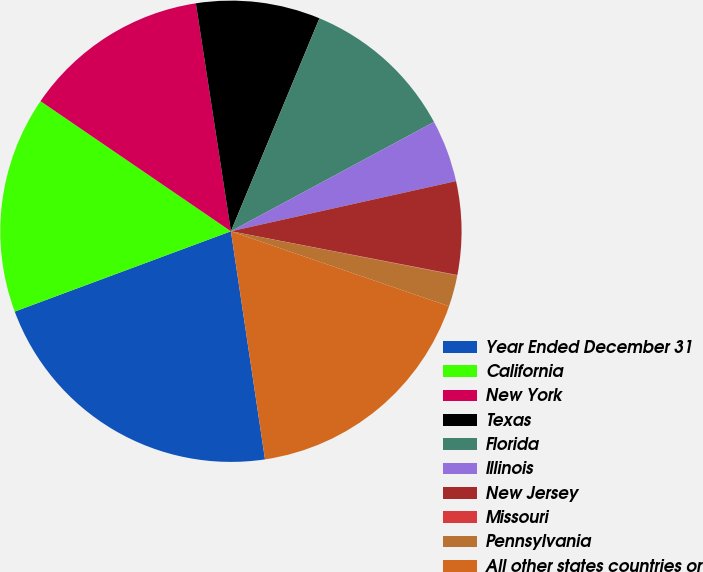Convert chart. <chart><loc_0><loc_0><loc_500><loc_500><pie_chart><fcel>Year Ended December 31<fcel>California<fcel>New York<fcel>Texas<fcel>Florida<fcel>Illinois<fcel>New Jersey<fcel>Missouri<fcel>Pennsylvania<fcel>All other states countries or<nl><fcel>21.7%<fcel>15.2%<fcel>13.03%<fcel>8.7%<fcel>10.87%<fcel>4.37%<fcel>6.53%<fcel>0.03%<fcel>2.2%<fcel>17.37%<nl></chart> 